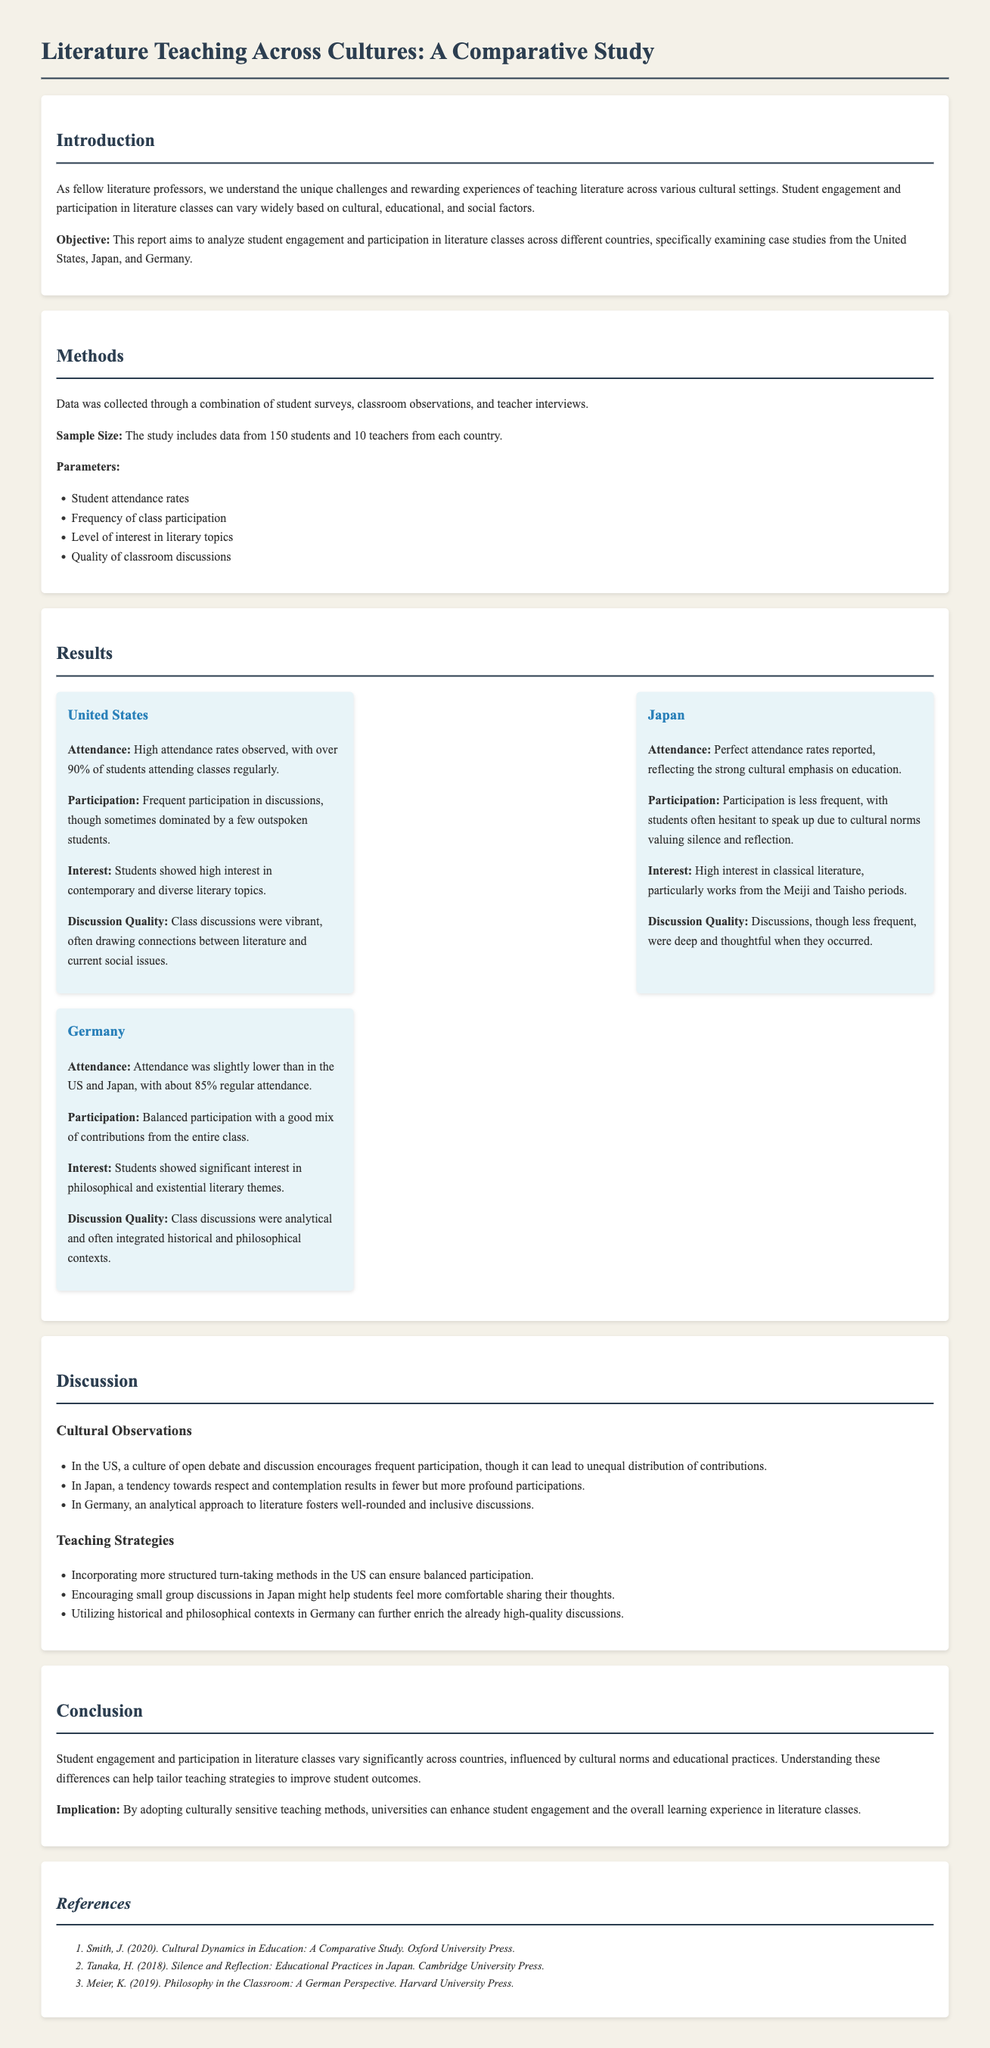What is the main aim of the report? The report aims to analyze student engagement and participation in literature classes across different countries.
Answer: Analyze student engagement and participation in literature classes How many teachers were included in the study? The study includes data from 10 teachers from each country.
Answer: 10 teachers What was the attendance percentage in the United States? Over 90% of students attending classes regularly indicates high attendance rates in the US.
Answer: Over 90% Which country reported perfect attendance rates? Perfect attendance rates were reported in Japan, reflecting the strong cultural emphasis on education.
Answer: Japan What strategy is suggested to improve participation in Japan? Encouraging small group discussions in Japan might help students feel more comfortable sharing their thoughts.
Answer: Small group discussions How is participation characterized in Germany? Participation in Germany is characterized as balanced with a good mix of contributions from the entire class.
Answer: Balanced participation What is the cultural norm influencing participation in Japan? Cultural norms valuing silence and reflection influence participation in Japan, leading to less frequent participation.
Answer: Silence and reflection Which literary themes do students in Germany show significant interest in? Students showed significant interest in philosophical and existential literary themes in Germany.
Answer: Philosophical and existential themes 